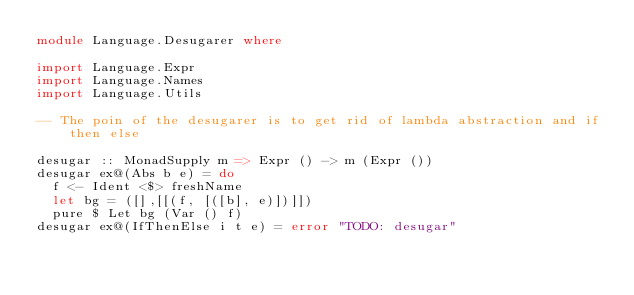Convert code to text. <code><loc_0><loc_0><loc_500><loc_500><_Haskell_>module Language.Desugarer where

import Language.Expr
import Language.Names
import Language.Utils

-- The poin of the desugarer is to get rid of lambda abstraction and if then else

desugar :: MonadSupply m => Expr () -> m (Expr ())
desugar ex@(Abs b e) = do
  f <- Ident <$> freshName
  let bg = ([],[[(f, [([b], e)])]])
  pure $ Let bg (Var () f)
desugar ex@(IfThenElse i t e) = error "TODO: desugar"


</code> 